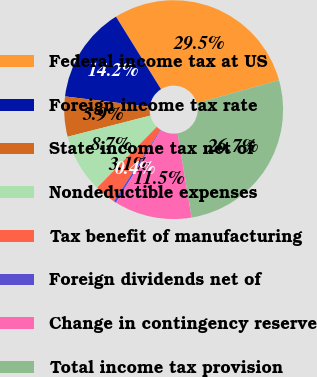<chart> <loc_0><loc_0><loc_500><loc_500><pie_chart><fcel>Federal income tax at US<fcel>Foreign income tax rate<fcel>State income tax net of<fcel>Nondeductible expenses<fcel>Tax benefit of manufacturing<fcel>Foreign dividends net of<fcel>Change in contingency reserve<fcel>Total income tax provision<nl><fcel>29.49%<fcel>14.23%<fcel>5.91%<fcel>8.68%<fcel>3.14%<fcel>0.36%<fcel>11.46%<fcel>26.72%<nl></chart> 